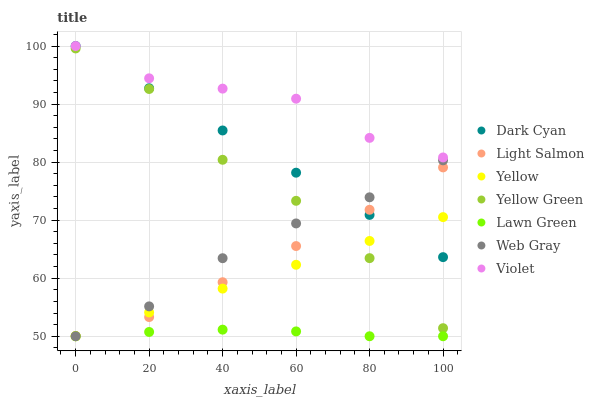Does Lawn Green have the minimum area under the curve?
Answer yes or no. Yes. Does Violet have the maximum area under the curve?
Answer yes or no. Yes. Does Light Salmon have the minimum area under the curve?
Answer yes or no. No. Does Light Salmon have the maximum area under the curve?
Answer yes or no. No. Is Yellow the smoothest?
Answer yes or no. Yes. Is Yellow Green the roughest?
Answer yes or no. Yes. Is Light Salmon the smoothest?
Answer yes or no. No. Is Light Salmon the roughest?
Answer yes or no. No. Does Lawn Green have the lowest value?
Answer yes or no. Yes. Does Light Salmon have the lowest value?
Answer yes or no. No. Does Dark Cyan have the highest value?
Answer yes or no. Yes. Does Light Salmon have the highest value?
Answer yes or no. No. Is Lawn Green less than Yellow Green?
Answer yes or no. Yes. Is Violet greater than Yellow?
Answer yes or no. Yes. Does Web Gray intersect Dark Cyan?
Answer yes or no. Yes. Is Web Gray less than Dark Cyan?
Answer yes or no. No. Is Web Gray greater than Dark Cyan?
Answer yes or no. No. Does Lawn Green intersect Yellow Green?
Answer yes or no. No. 